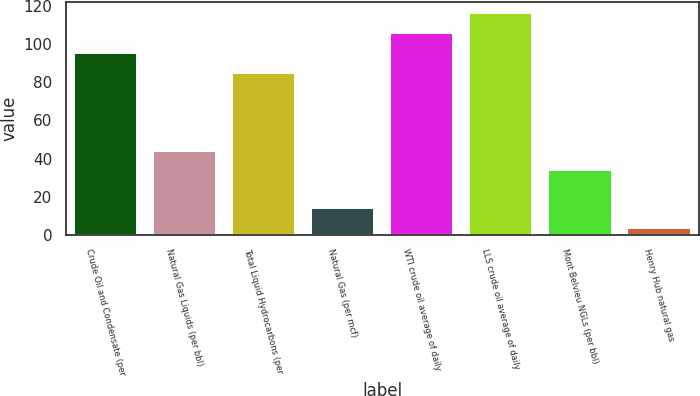<chart> <loc_0><loc_0><loc_500><loc_500><bar_chart><fcel>Crude Oil and Condensate (per<fcel>Natural Gas Liquids (per bbl)<fcel>Total Liquid Hydrocarbons (per<fcel>Natural Gas (per mcf)<fcel>WTI crude oil average of daily<fcel>LLS crude oil average of daily<fcel>Mont Belvieu NGLs (per bbl)<fcel>Henry Hub natural gas<nl><fcel>95.57<fcel>44.15<fcel>85.2<fcel>14.02<fcel>105.94<fcel>116.31<fcel>33.78<fcel>3.65<nl></chart> 